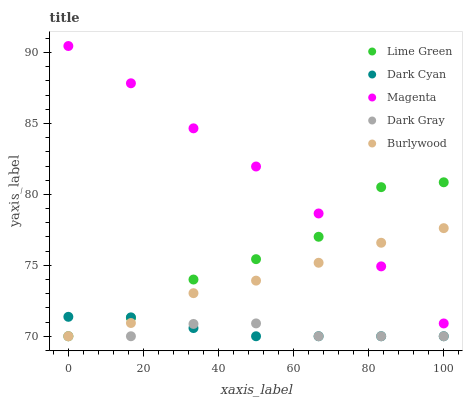Does Dark Gray have the minimum area under the curve?
Answer yes or no. Yes. Does Magenta have the maximum area under the curve?
Answer yes or no. Yes. Does Magenta have the minimum area under the curve?
Answer yes or no. No. Does Dark Gray have the maximum area under the curve?
Answer yes or no. No. Is Dark Cyan the smoothest?
Answer yes or no. Yes. Is Lime Green the roughest?
Answer yes or no. Yes. Is Dark Gray the smoothest?
Answer yes or no. No. Is Dark Gray the roughest?
Answer yes or no. No. Does Dark Cyan have the lowest value?
Answer yes or no. Yes. Does Magenta have the lowest value?
Answer yes or no. No. Does Magenta have the highest value?
Answer yes or no. Yes. Does Dark Gray have the highest value?
Answer yes or no. No. Is Dark Cyan less than Magenta?
Answer yes or no. Yes. Is Magenta greater than Dark Gray?
Answer yes or no. Yes. Does Lime Green intersect Dark Gray?
Answer yes or no. Yes. Is Lime Green less than Dark Gray?
Answer yes or no. No. Is Lime Green greater than Dark Gray?
Answer yes or no. No. Does Dark Cyan intersect Magenta?
Answer yes or no. No. 